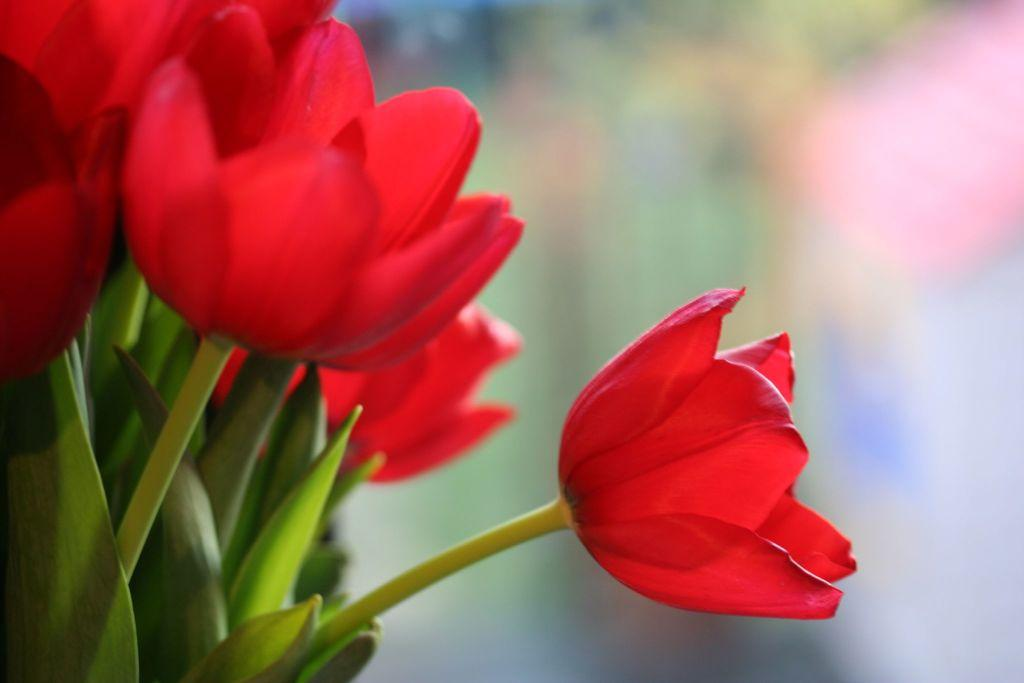What type of plants can be seen in the image? There are flowers in the image. How are the flowers depicted in the image? The flowers are truncated towards the top of the image. What can be observed about the background of the image? The background of the image is blurred. What is the cause of the increased profit in the image? There is no mention of profit or any financial aspect in the image, as it features flowers and a blurred background. 